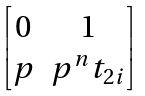Convert formula to latex. <formula><loc_0><loc_0><loc_500><loc_500>\begin{bmatrix} 0 & 1 \\ p & p ^ { n } t _ { 2 i } \end{bmatrix}</formula> 